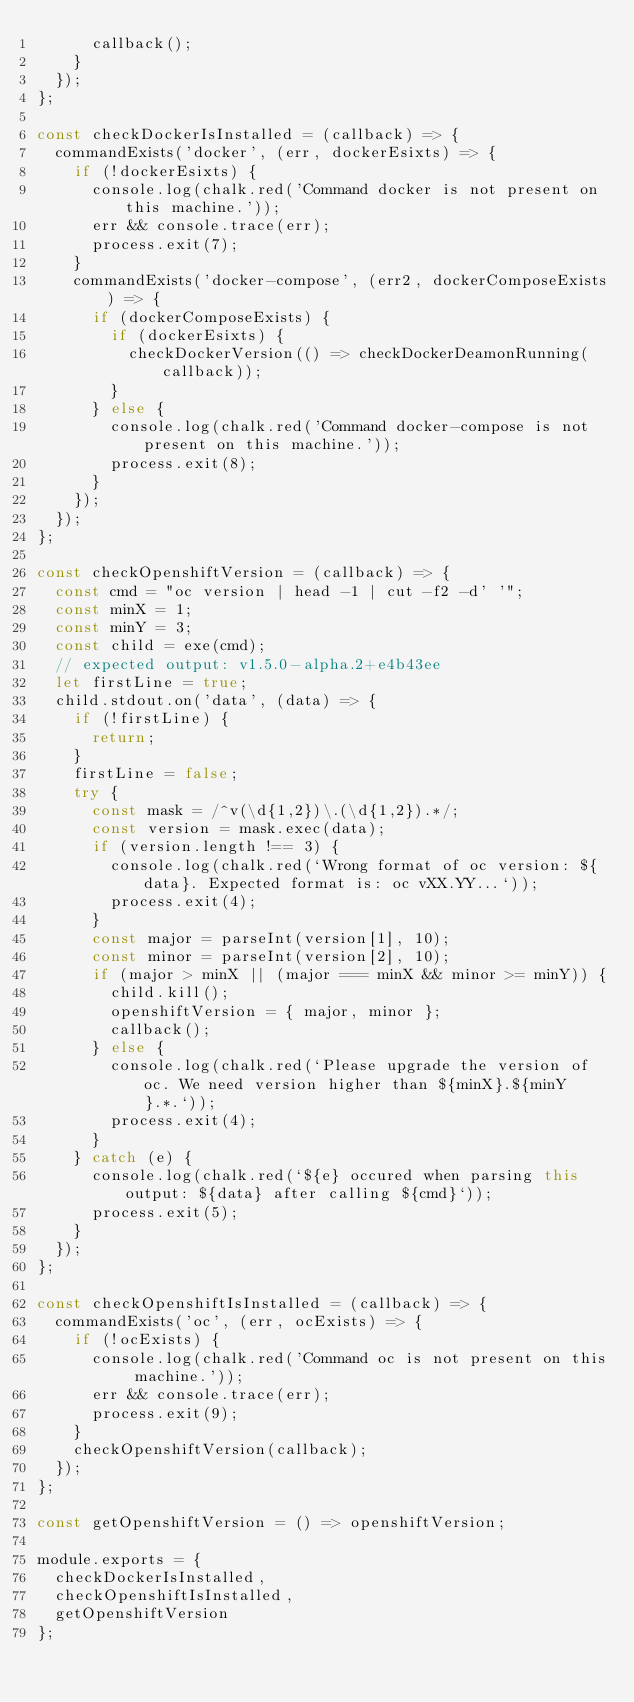<code> <loc_0><loc_0><loc_500><loc_500><_JavaScript_>      callback();
    }
  });
};

const checkDockerIsInstalled = (callback) => {
  commandExists('docker', (err, dockerEsixts) => {
    if (!dockerEsixts) {
      console.log(chalk.red('Command docker is not present on this machine.'));
      err && console.trace(err);
      process.exit(7);
    }
    commandExists('docker-compose', (err2, dockerComposeExists) => {
      if (dockerComposeExists) {
        if (dockerEsixts) {
          checkDockerVersion(() => checkDockerDeamonRunning(callback));
        }
      } else {
        console.log(chalk.red('Command docker-compose is not present on this machine.'));
        process.exit(8);
      }
    });
  });
};

const checkOpenshiftVersion = (callback) => {
  const cmd = "oc version | head -1 | cut -f2 -d' '";
  const minX = 1;
  const minY = 3;
  const child = exe(cmd);
  // expected output: v1.5.0-alpha.2+e4b43ee
  let firstLine = true;
  child.stdout.on('data', (data) => {
    if (!firstLine) {
      return;
    }
    firstLine = false;
    try {
      const mask = /^v(\d{1,2})\.(\d{1,2}).*/;
      const version = mask.exec(data);
      if (version.length !== 3) {
        console.log(chalk.red(`Wrong format of oc version: ${data}. Expected format is: oc vXX.YY...`));
        process.exit(4);
      }
      const major = parseInt(version[1], 10);
      const minor = parseInt(version[2], 10);
      if (major > minX || (major === minX && minor >= minY)) {
        child.kill();
        openshiftVersion = { major, minor };
        callback();
      } else {
        console.log(chalk.red(`Please upgrade the version of oc. We need version higher than ${minX}.${minY}.*.`));
        process.exit(4);
      }
    } catch (e) {
      console.log(chalk.red(`${e} occured when parsing this output: ${data} after calling ${cmd}`));
      process.exit(5);
    }
  });
};

const checkOpenshiftIsInstalled = (callback) => {
  commandExists('oc', (err, ocExists) => {
    if (!ocExists) {
      console.log(chalk.red('Command oc is not present on this machine.'));
      err && console.trace(err);
      process.exit(9);
    }
    checkOpenshiftVersion(callback);
  });
};

const getOpenshiftVersion = () => openshiftVersion;

module.exports = {
  checkDockerIsInstalled,
  checkOpenshiftIsInstalled,
  getOpenshiftVersion
};
</code> 